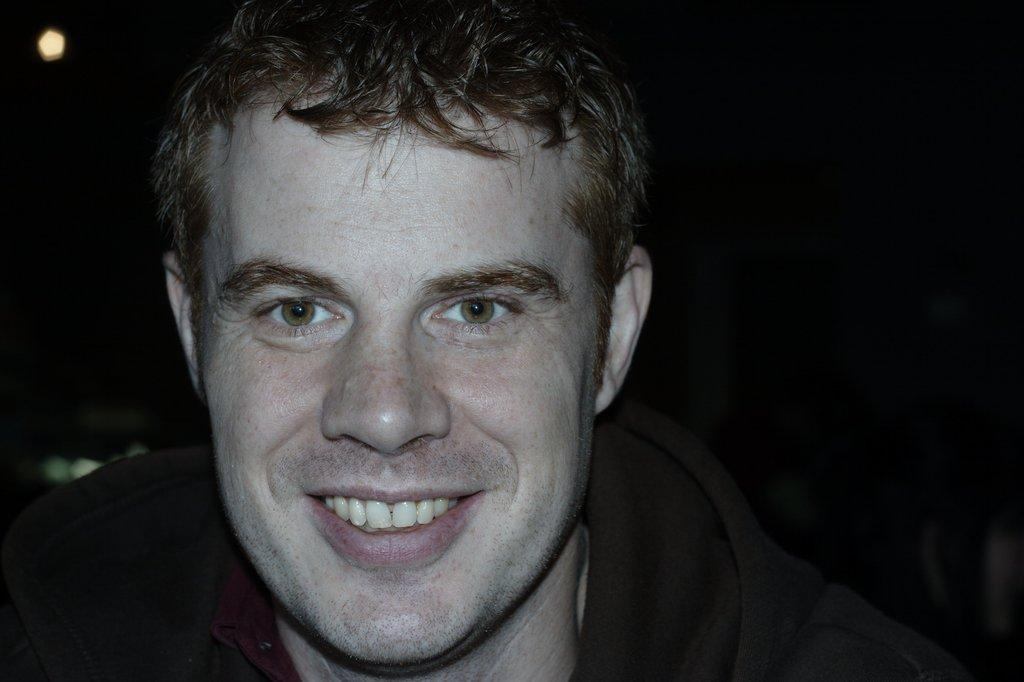What is the gender of the person in the image? The person in the image is a man. What can be observed about the man's facial expression? The man is smiling in the image. What is the color of the man's eyes? The man's eye color is brown. What is the color of the man's hair? The man's hair color is brown. What type of toothbrush is the man using in the image? There is no toothbrush present in the image. What force is being applied by the man in the image? The image does not depict any force being applied by the man. 